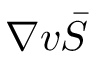<formula> <loc_0><loc_0><loc_500><loc_500>\nabla v \bar { S }</formula> 